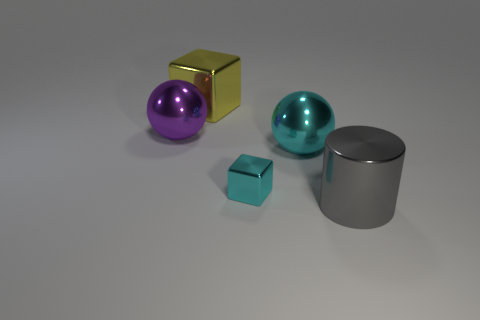Are there any other things that are the same size as the cyan shiny block?
Offer a terse response. No. There is a cube to the right of the big yellow shiny block; is its size the same as the purple shiny object in front of the large yellow thing?
Give a very brief answer. No. There is another metallic object that is the same shape as the tiny object; what size is it?
Offer a terse response. Large. There is a gray shiny thing; does it have the same size as the metal cube in front of the cyan metallic sphere?
Your response must be concise. No. There is a big sphere left of the big yellow shiny cube; are there any objects that are behind it?
Your response must be concise. Yes. What shape is the object that is behind the big purple sphere?
Keep it short and to the point. Cube. What color is the shiny sphere to the right of the cube that is in front of the large yellow block?
Give a very brief answer. Cyan. Is the size of the metallic cylinder the same as the cyan block?
Give a very brief answer. No. What number of purple matte things have the same size as the gray metal cylinder?
Offer a very short reply. 0. What color is the other sphere that is made of the same material as the purple ball?
Offer a very short reply. Cyan. 